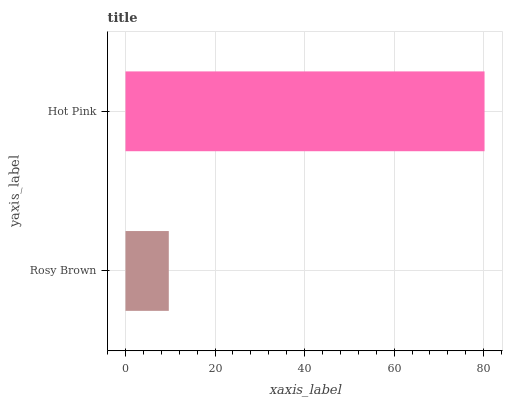Is Rosy Brown the minimum?
Answer yes or no. Yes. Is Hot Pink the maximum?
Answer yes or no. Yes. Is Hot Pink the minimum?
Answer yes or no. No. Is Hot Pink greater than Rosy Brown?
Answer yes or no. Yes. Is Rosy Brown less than Hot Pink?
Answer yes or no. Yes. Is Rosy Brown greater than Hot Pink?
Answer yes or no. No. Is Hot Pink less than Rosy Brown?
Answer yes or no. No. Is Hot Pink the high median?
Answer yes or no. Yes. Is Rosy Brown the low median?
Answer yes or no. Yes. Is Rosy Brown the high median?
Answer yes or no. No. Is Hot Pink the low median?
Answer yes or no. No. 